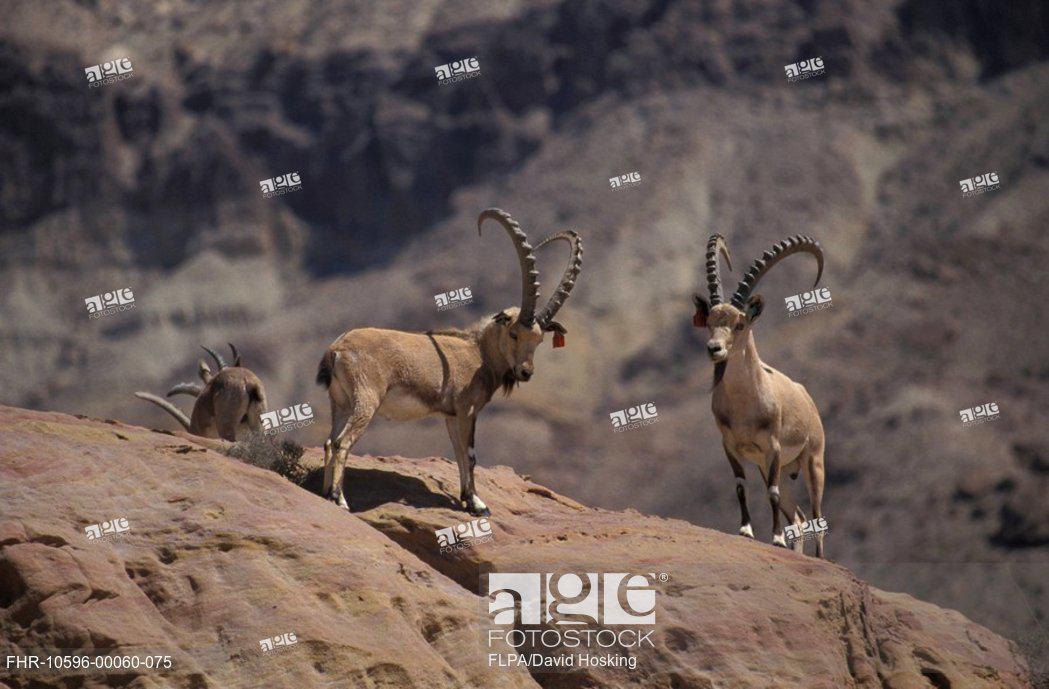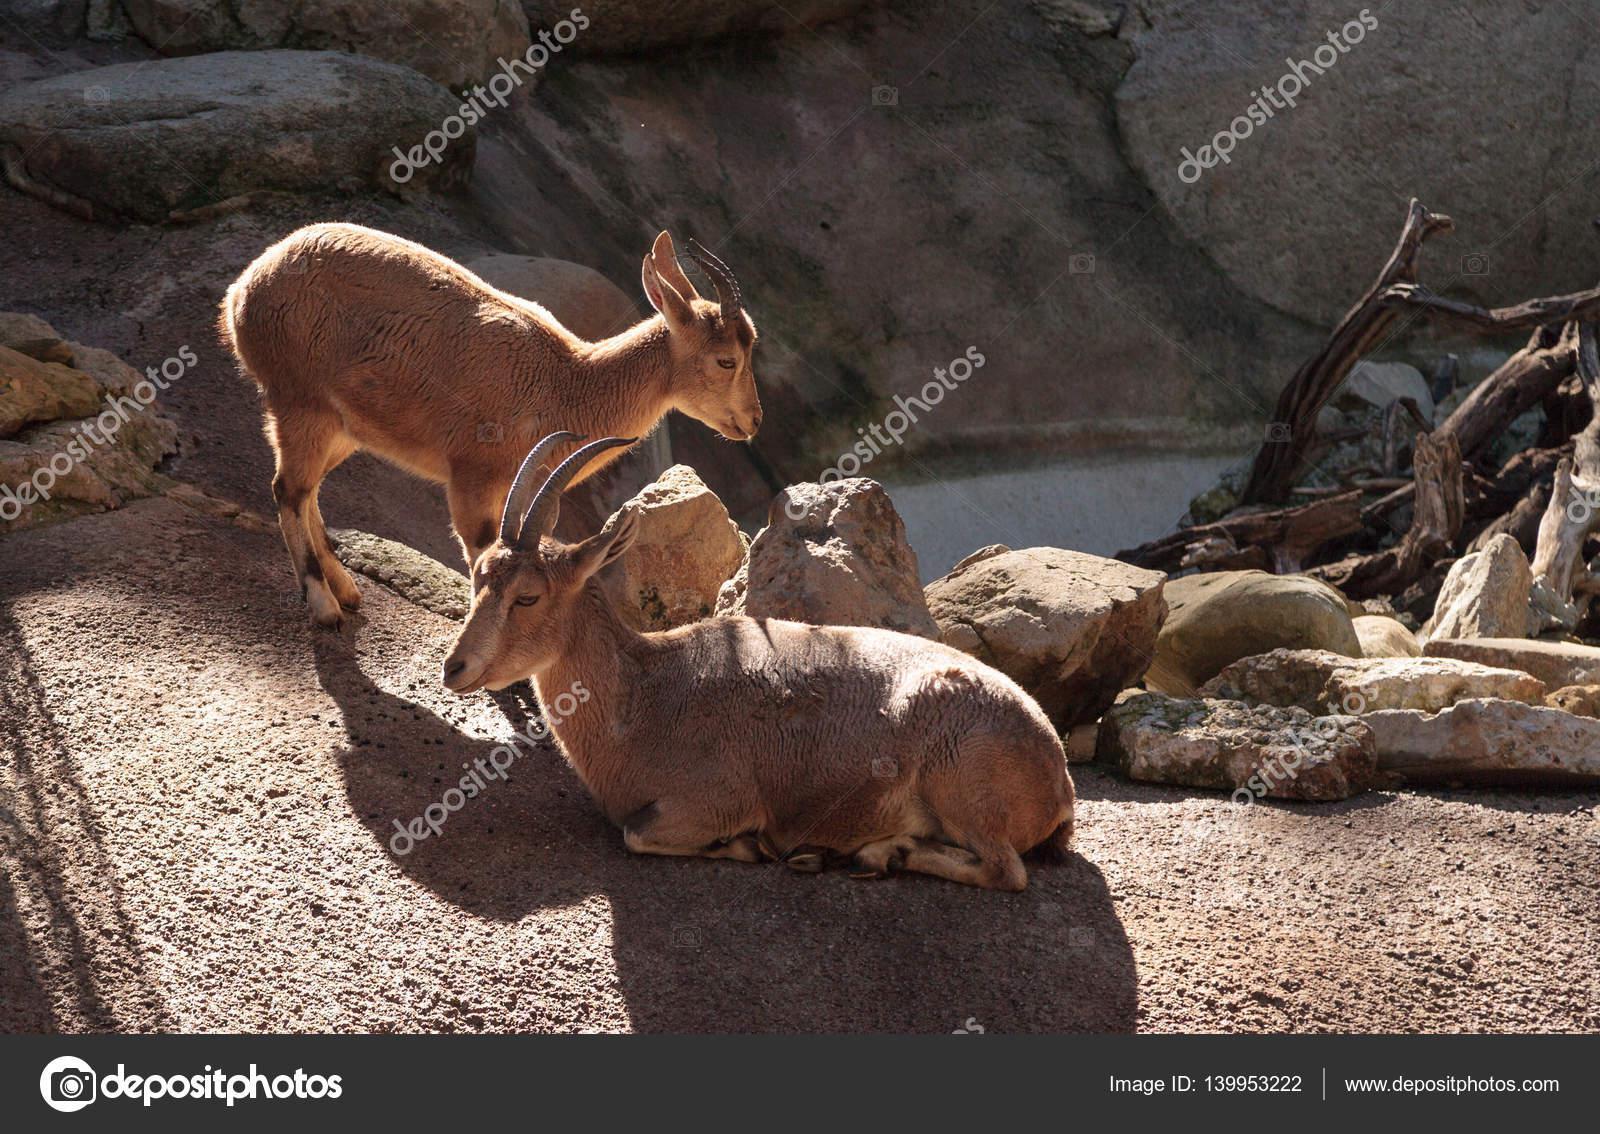The first image is the image on the left, the second image is the image on the right. For the images displayed, is the sentence "A goat in the right image is laying down." factually correct? Answer yes or no. Yes. The first image is the image on the left, the second image is the image on the right. Given the left and right images, does the statement "Each image contains only one horned animal, and one image shows an animal with long curled horns, while the other shows an animal with much shorter horns." hold true? Answer yes or no. No. 